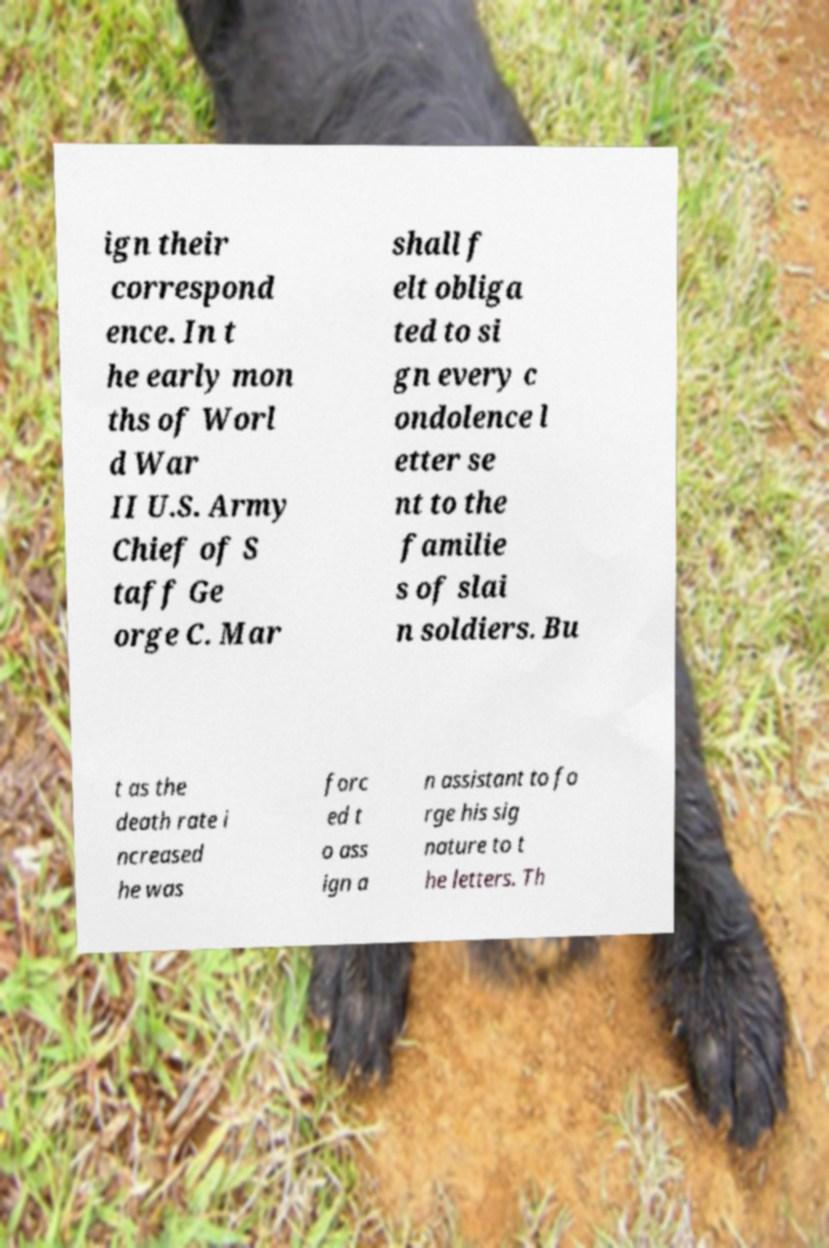There's text embedded in this image that I need extracted. Can you transcribe it verbatim? ign their correspond ence. In t he early mon ths of Worl d War II U.S. Army Chief of S taff Ge orge C. Mar shall f elt obliga ted to si gn every c ondolence l etter se nt to the familie s of slai n soldiers. Bu t as the death rate i ncreased he was forc ed t o ass ign a n assistant to fo rge his sig nature to t he letters. Th 